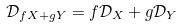Convert formula to latex. <formula><loc_0><loc_0><loc_500><loc_500>\mathcal { D } _ { f X + g Y } = f \mathcal { D } _ { X } + g \mathcal { D } _ { Y }</formula> 